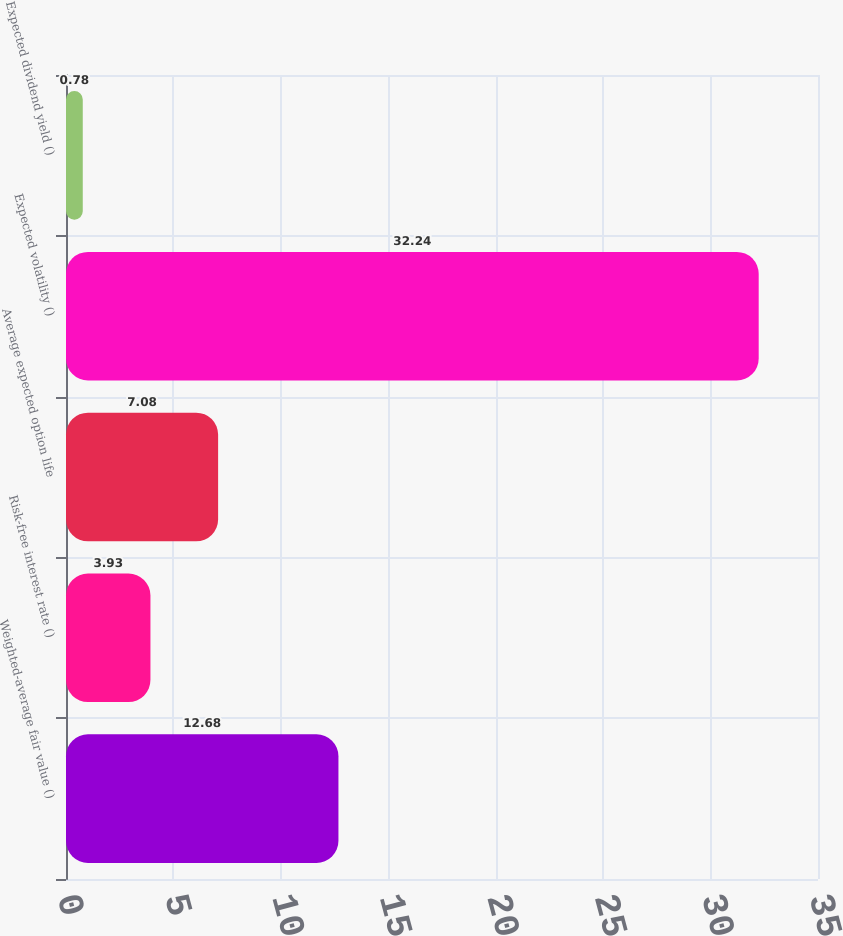Convert chart to OTSL. <chart><loc_0><loc_0><loc_500><loc_500><bar_chart><fcel>Weighted-average fair value ()<fcel>Risk-free interest rate ()<fcel>Average expected option life<fcel>Expected volatility ()<fcel>Expected dividend yield ()<nl><fcel>12.68<fcel>3.93<fcel>7.08<fcel>32.24<fcel>0.78<nl></chart> 